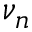<formula> <loc_0><loc_0><loc_500><loc_500>\nu _ { n }</formula> 